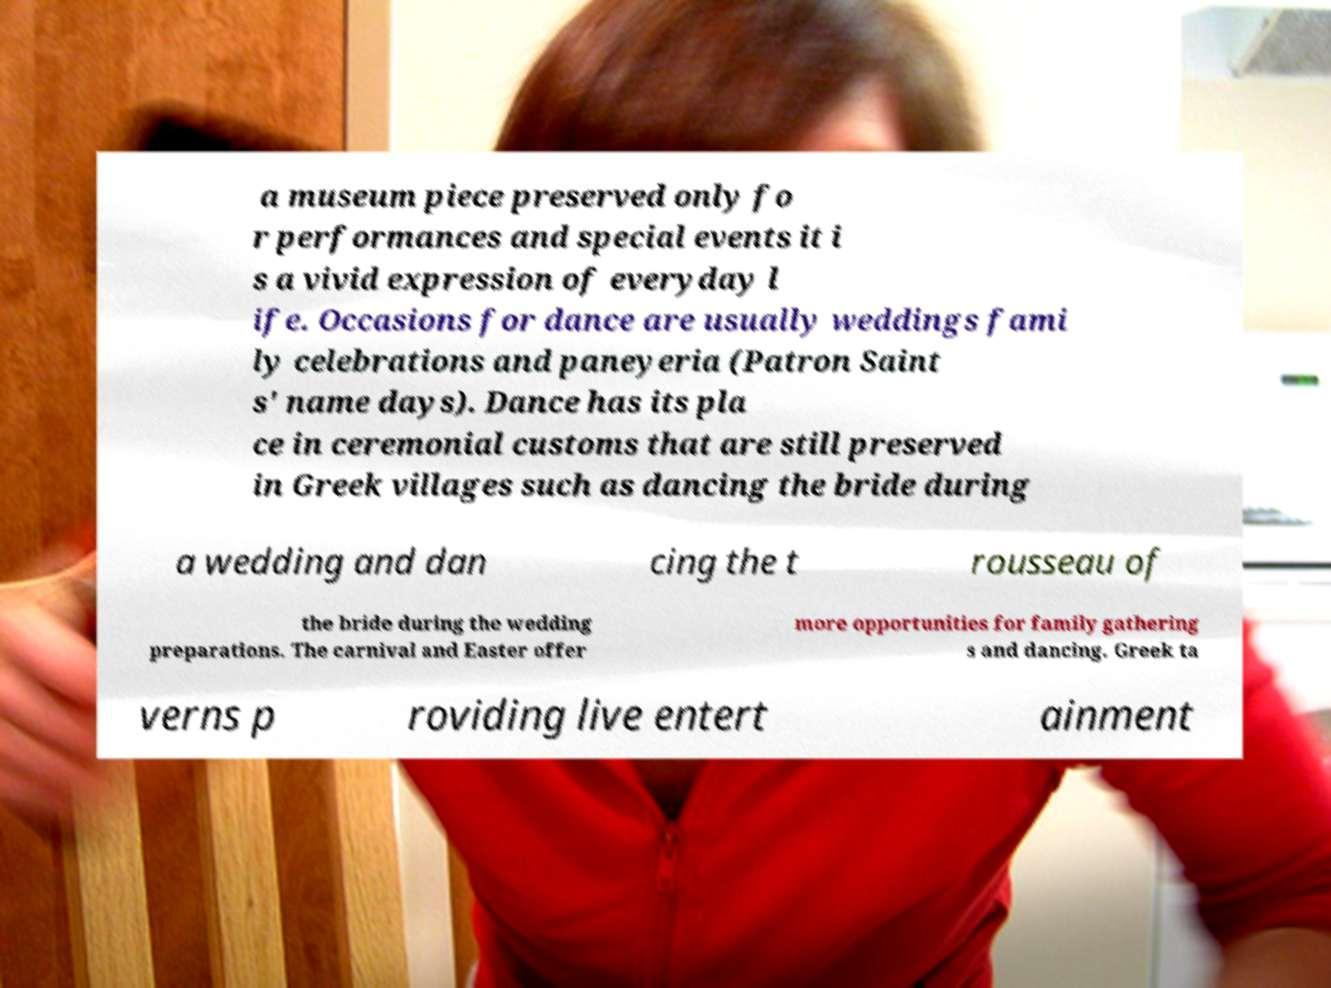Please identify and transcribe the text found in this image. a museum piece preserved only fo r performances and special events it i s a vivid expression of everyday l ife. Occasions for dance are usually weddings fami ly celebrations and paneyeria (Patron Saint s' name days). Dance has its pla ce in ceremonial customs that are still preserved in Greek villages such as dancing the bride during a wedding and dan cing the t rousseau of the bride during the wedding preparations. The carnival and Easter offer more opportunities for family gathering s and dancing. Greek ta verns p roviding live entert ainment 